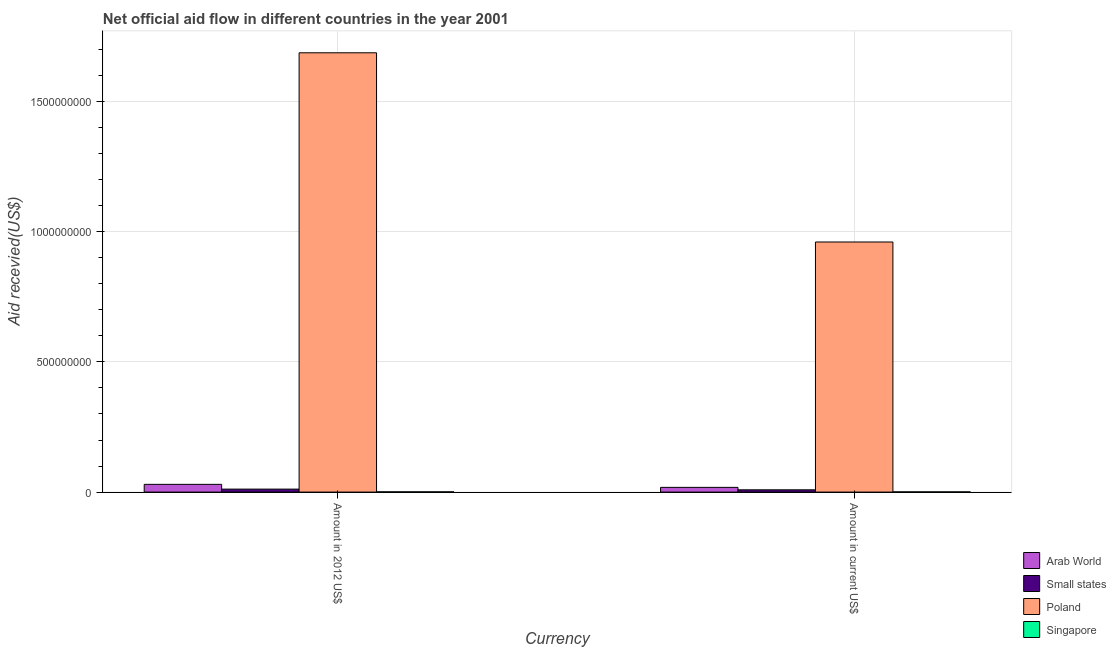How many groups of bars are there?
Offer a very short reply. 2. How many bars are there on the 1st tick from the left?
Provide a short and direct response. 4. What is the label of the 1st group of bars from the left?
Your answer should be very brief. Amount in 2012 US$. What is the amount of aid received(expressed in us$) in Arab World?
Provide a short and direct response. 1.81e+07. Across all countries, what is the maximum amount of aid received(expressed in 2012 us$)?
Your response must be concise. 1.69e+09. Across all countries, what is the minimum amount of aid received(expressed in 2012 us$)?
Make the answer very short. 9.60e+05. In which country was the amount of aid received(expressed in us$) maximum?
Offer a terse response. Poland. In which country was the amount of aid received(expressed in us$) minimum?
Provide a succinct answer. Singapore. What is the total amount of aid received(expressed in us$) in the graph?
Give a very brief answer. 9.88e+08. What is the difference between the amount of aid received(expressed in 2012 us$) in Small states and that in Poland?
Offer a very short reply. -1.68e+09. What is the difference between the amount of aid received(expressed in 2012 us$) in Small states and the amount of aid received(expressed in us$) in Poland?
Provide a short and direct response. -9.49e+08. What is the average amount of aid received(expressed in us$) per country?
Provide a short and direct response. 2.47e+08. What is the difference between the amount of aid received(expressed in 2012 us$) and amount of aid received(expressed in us$) in Singapore?
Give a very brief answer. 1.10e+05. In how many countries, is the amount of aid received(expressed in 2012 us$) greater than 700000000 US$?
Your answer should be compact. 1. What is the ratio of the amount of aid received(expressed in 2012 us$) in Arab World to that in Singapore?
Give a very brief answer. 30.94. Is the amount of aid received(expressed in us$) in Small states less than that in Poland?
Your answer should be very brief. Yes. What does the 3rd bar from the left in Amount in 2012 US$ represents?
Give a very brief answer. Poland. What does the 3rd bar from the right in Amount in current US$ represents?
Your response must be concise. Small states. Are all the bars in the graph horizontal?
Provide a short and direct response. No. How many countries are there in the graph?
Make the answer very short. 4. What is the difference between two consecutive major ticks on the Y-axis?
Provide a short and direct response. 5.00e+08. Are the values on the major ticks of Y-axis written in scientific E-notation?
Keep it short and to the point. No. Does the graph contain any zero values?
Offer a terse response. No. Does the graph contain grids?
Provide a succinct answer. Yes. Where does the legend appear in the graph?
Offer a very short reply. Bottom right. What is the title of the graph?
Make the answer very short. Net official aid flow in different countries in the year 2001. What is the label or title of the X-axis?
Your answer should be compact. Currency. What is the label or title of the Y-axis?
Provide a succinct answer. Aid recevied(US$). What is the Aid recevied(US$) of Arab World in Amount in 2012 US$?
Make the answer very short. 2.97e+07. What is the Aid recevied(US$) of Small states in Amount in 2012 US$?
Offer a terse response. 1.14e+07. What is the Aid recevied(US$) of Poland in Amount in 2012 US$?
Give a very brief answer. 1.69e+09. What is the Aid recevied(US$) of Singapore in Amount in 2012 US$?
Offer a terse response. 9.60e+05. What is the Aid recevied(US$) of Arab World in Amount in current US$?
Your answer should be very brief. 1.81e+07. What is the Aid recevied(US$) in Small states in Amount in current US$?
Make the answer very short. 8.68e+06. What is the Aid recevied(US$) in Poland in Amount in current US$?
Keep it short and to the point. 9.60e+08. What is the Aid recevied(US$) of Singapore in Amount in current US$?
Your answer should be compact. 8.50e+05. Across all Currency, what is the maximum Aid recevied(US$) of Arab World?
Give a very brief answer. 2.97e+07. Across all Currency, what is the maximum Aid recevied(US$) in Small states?
Your response must be concise. 1.14e+07. Across all Currency, what is the maximum Aid recevied(US$) of Poland?
Keep it short and to the point. 1.69e+09. Across all Currency, what is the maximum Aid recevied(US$) of Singapore?
Provide a short and direct response. 9.60e+05. Across all Currency, what is the minimum Aid recevied(US$) of Arab World?
Your answer should be compact. 1.81e+07. Across all Currency, what is the minimum Aid recevied(US$) in Small states?
Offer a very short reply. 8.68e+06. Across all Currency, what is the minimum Aid recevied(US$) in Poland?
Provide a short and direct response. 9.60e+08. Across all Currency, what is the minimum Aid recevied(US$) in Singapore?
Give a very brief answer. 8.50e+05. What is the total Aid recevied(US$) in Arab World in the graph?
Your response must be concise. 4.78e+07. What is the total Aid recevied(US$) in Small states in the graph?
Provide a succinct answer. 2.01e+07. What is the total Aid recevied(US$) of Poland in the graph?
Provide a succinct answer. 2.65e+09. What is the total Aid recevied(US$) of Singapore in the graph?
Provide a short and direct response. 1.81e+06. What is the difference between the Aid recevied(US$) of Arab World in Amount in 2012 US$ and that in Amount in current US$?
Provide a succinct answer. 1.16e+07. What is the difference between the Aid recevied(US$) of Small states in Amount in 2012 US$ and that in Amount in current US$?
Your response must be concise. 2.70e+06. What is the difference between the Aid recevied(US$) in Poland in Amount in 2012 US$ and that in Amount in current US$?
Ensure brevity in your answer.  7.27e+08. What is the difference between the Aid recevied(US$) of Singapore in Amount in 2012 US$ and that in Amount in current US$?
Provide a succinct answer. 1.10e+05. What is the difference between the Aid recevied(US$) of Arab World in Amount in 2012 US$ and the Aid recevied(US$) of Small states in Amount in current US$?
Keep it short and to the point. 2.10e+07. What is the difference between the Aid recevied(US$) of Arab World in Amount in 2012 US$ and the Aid recevied(US$) of Poland in Amount in current US$?
Give a very brief answer. -9.31e+08. What is the difference between the Aid recevied(US$) in Arab World in Amount in 2012 US$ and the Aid recevied(US$) in Singapore in Amount in current US$?
Provide a short and direct response. 2.88e+07. What is the difference between the Aid recevied(US$) in Small states in Amount in 2012 US$ and the Aid recevied(US$) in Poland in Amount in current US$?
Your response must be concise. -9.49e+08. What is the difference between the Aid recevied(US$) in Small states in Amount in 2012 US$ and the Aid recevied(US$) in Singapore in Amount in current US$?
Provide a succinct answer. 1.05e+07. What is the difference between the Aid recevied(US$) of Poland in Amount in 2012 US$ and the Aid recevied(US$) of Singapore in Amount in current US$?
Ensure brevity in your answer.  1.69e+09. What is the average Aid recevied(US$) in Arab World per Currency?
Give a very brief answer. 2.39e+07. What is the average Aid recevied(US$) of Small states per Currency?
Ensure brevity in your answer.  1.00e+07. What is the average Aid recevied(US$) in Poland per Currency?
Your answer should be compact. 1.32e+09. What is the average Aid recevied(US$) in Singapore per Currency?
Your response must be concise. 9.05e+05. What is the difference between the Aid recevied(US$) in Arab World and Aid recevied(US$) in Small states in Amount in 2012 US$?
Ensure brevity in your answer.  1.83e+07. What is the difference between the Aid recevied(US$) of Arab World and Aid recevied(US$) of Poland in Amount in 2012 US$?
Offer a very short reply. -1.66e+09. What is the difference between the Aid recevied(US$) in Arab World and Aid recevied(US$) in Singapore in Amount in 2012 US$?
Give a very brief answer. 2.87e+07. What is the difference between the Aid recevied(US$) of Small states and Aid recevied(US$) of Poland in Amount in 2012 US$?
Keep it short and to the point. -1.68e+09. What is the difference between the Aid recevied(US$) of Small states and Aid recevied(US$) of Singapore in Amount in 2012 US$?
Provide a succinct answer. 1.04e+07. What is the difference between the Aid recevied(US$) of Poland and Aid recevied(US$) of Singapore in Amount in 2012 US$?
Provide a succinct answer. 1.69e+09. What is the difference between the Aid recevied(US$) of Arab World and Aid recevied(US$) of Small states in Amount in current US$?
Your response must be concise. 9.43e+06. What is the difference between the Aid recevied(US$) in Arab World and Aid recevied(US$) in Poland in Amount in current US$?
Your response must be concise. -9.42e+08. What is the difference between the Aid recevied(US$) in Arab World and Aid recevied(US$) in Singapore in Amount in current US$?
Ensure brevity in your answer.  1.73e+07. What is the difference between the Aid recevied(US$) in Small states and Aid recevied(US$) in Poland in Amount in current US$?
Ensure brevity in your answer.  -9.52e+08. What is the difference between the Aid recevied(US$) of Small states and Aid recevied(US$) of Singapore in Amount in current US$?
Your answer should be very brief. 7.83e+06. What is the difference between the Aid recevied(US$) in Poland and Aid recevied(US$) in Singapore in Amount in current US$?
Provide a short and direct response. 9.60e+08. What is the ratio of the Aid recevied(US$) of Arab World in Amount in 2012 US$ to that in Amount in current US$?
Make the answer very short. 1.64. What is the ratio of the Aid recevied(US$) of Small states in Amount in 2012 US$ to that in Amount in current US$?
Your response must be concise. 1.31. What is the ratio of the Aid recevied(US$) in Poland in Amount in 2012 US$ to that in Amount in current US$?
Your answer should be very brief. 1.76. What is the ratio of the Aid recevied(US$) of Singapore in Amount in 2012 US$ to that in Amount in current US$?
Provide a short and direct response. 1.13. What is the difference between the highest and the second highest Aid recevied(US$) of Arab World?
Your response must be concise. 1.16e+07. What is the difference between the highest and the second highest Aid recevied(US$) in Small states?
Your answer should be very brief. 2.70e+06. What is the difference between the highest and the second highest Aid recevied(US$) of Poland?
Offer a very short reply. 7.27e+08. What is the difference between the highest and the lowest Aid recevied(US$) of Arab World?
Your response must be concise. 1.16e+07. What is the difference between the highest and the lowest Aid recevied(US$) of Small states?
Keep it short and to the point. 2.70e+06. What is the difference between the highest and the lowest Aid recevied(US$) of Poland?
Offer a terse response. 7.27e+08. 